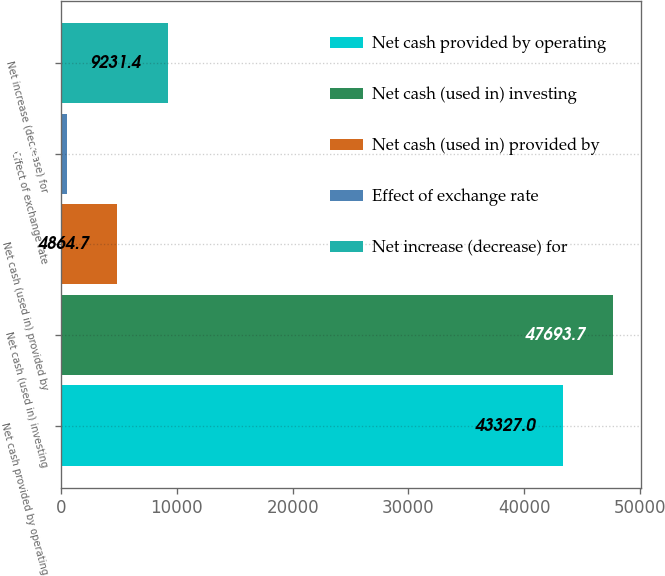Convert chart. <chart><loc_0><loc_0><loc_500><loc_500><bar_chart><fcel>Net cash provided by operating<fcel>Net cash (used in) investing<fcel>Net cash (used in) provided by<fcel>Effect of exchange rate<fcel>Net increase (decrease) for<nl><fcel>43327<fcel>47693.7<fcel>4864.7<fcel>498<fcel>9231.4<nl></chart> 